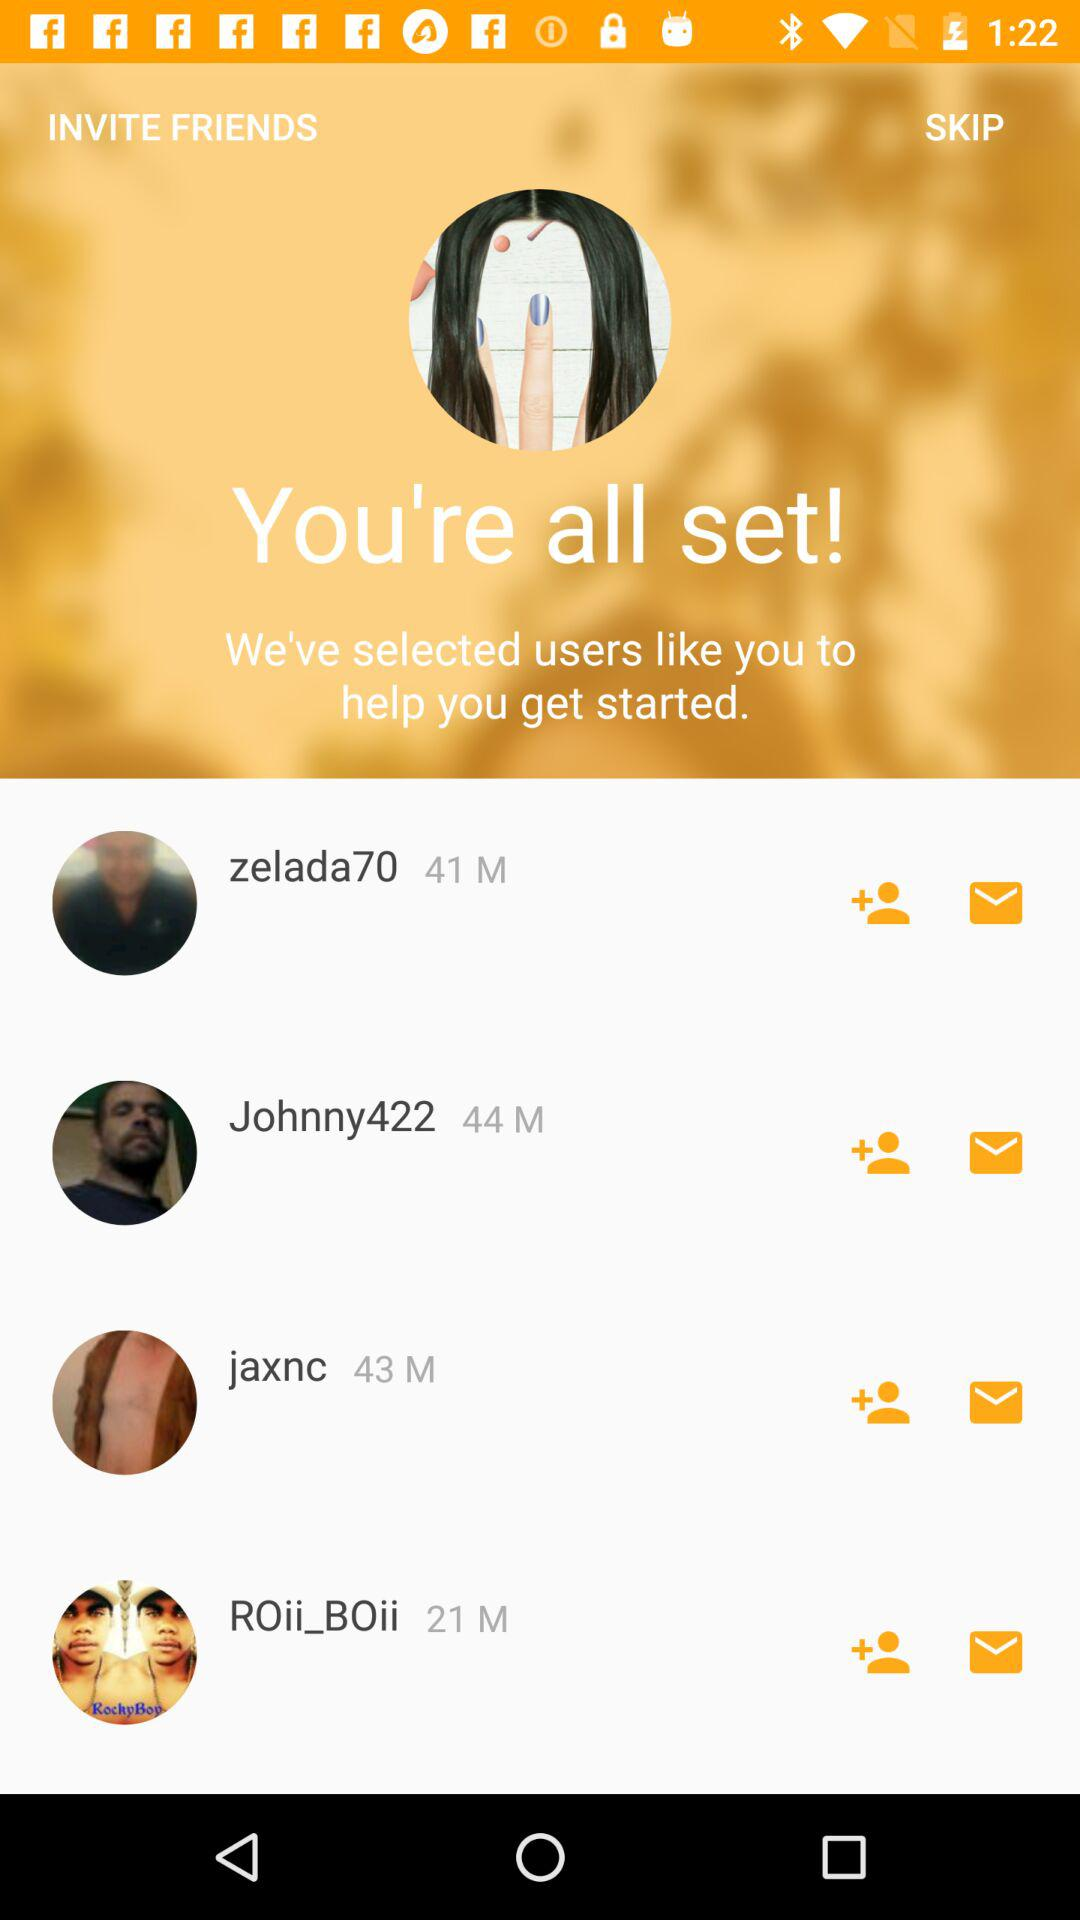How many people are in the selected users?
Answer the question using a single word or phrase. 4 